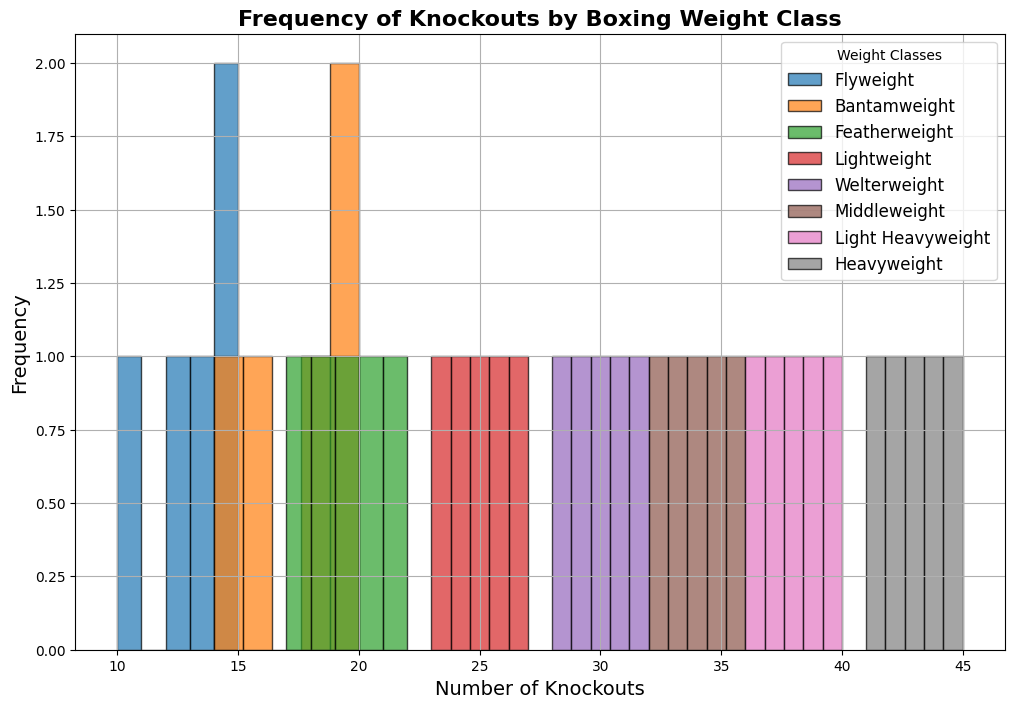What is the weight class with the highest number of knockouts? The weight class that has the bars centred around the highest values indicates the highest number of knockouts. From the histogram, the Heavyweight class has knockouts in the range of 41 to 45, which is higher than any other class.
Answer: Heavyweight Which weight class has the most frequent occurrence of knockouts in the 20-25 range? To answer this, we need to look at the height of the bars in the 20-25 range for each weight class. The Featherweight class has the highest frequency in this range.
Answer: Featherweight What is the difference in the average number of knockouts between Flyweight and Welterweight classes? Calculate the average knockouts for each class. For Flyweight (13+15+10+12+14)/5 = 12.8 and for Welterweight (28+32+30+29+31)/5 = 30. Difference is 30 - 12.8 = 17.2.
Answer: 17.2 How many weight classes have their highest frequency bar in the range of 35-40 knockouts? Examine each weight class and count those with their highest frequency bars in the range of 35-40. Light Heavyweight is the only class with its highest frequency in this range.
Answer: 1 Which weight class has more knockouts overall, Bantamweight or Middleweight? Consider the total number of knockouts. Sum the knockouts for each class. Bantamweight: 18+16+19+14+20 = 87. Middleweight: 34+35+33+36+32 = 170. Middleweight has more knockouts in total.
Answer: Middleweight What is the median number of knockouts for Lightweight class? Arrange the knockouts for Lightweight in ascending order: 23, 24, 25, 26, 27. The median is the middle value, which is 25.
Answer: 25 Which weight class has the smallest range of knockout values? Calculate the range (maximum - minimum) for each weight class. Flyweight: 15-10 = 5; Bantamweight: 20-14 = 6; Featherweight: 22-17 = 5; Lightweight: 27-23 = 4; Welterweight: 32-28 = 4; Middleweight: 36-32 = 4; Light Heavyweight: 40-36 = 4; Heavyweight: 45-41=4. Lightweight, Welterweight, Middleweight, Light Heavyweight, and Heavyweight share the smallest range of 4.
Answer: Lightweight, Welterweight, Middleweight, Light Heavyweight, Heavyweight What is the ratio of the highest knockout frequency in the Lightweight class to the highest knockout frequency in the Featherweight class? Identify the highest frequency bar in Lightweight and Featherweight from the histogram. Both classes have their highest frequency (most occurrences) the same. Therefore, the ratio is 1:1.
Answer: 1:1 Which weight class shows the most uniform distribution of knockouts? Visualize the histogram and identify the weight class where the bars are the most evenly spread. The Light Heavyweight class appears to have the most uniform distribution.
Answer: Light Heavyweight 